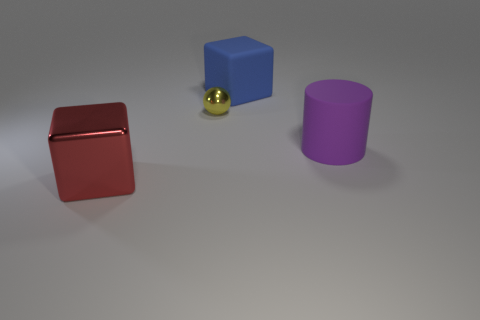How many objects are big matte cubes or red metallic things?
Keep it short and to the point. 2. Do the matte cylinder and the tiny metallic thing have the same color?
Offer a very short reply. No. Are there any other things that have the same size as the purple cylinder?
Make the answer very short. Yes. There is a small yellow shiny thing that is behind the red object that is to the left of the large rubber cylinder; what is its shape?
Give a very brief answer. Sphere. Is the number of large things less than the number of tiny shiny spheres?
Your response must be concise. No. There is a thing that is in front of the tiny yellow object and behind the large metal block; what size is it?
Ensure brevity in your answer.  Large. Does the yellow metal thing have the same size as the purple matte object?
Give a very brief answer. No. Do the matte object in front of the small ball and the tiny metallic thing have the same color?
Your response must be concise. No. How many large red blocks are behind the small metal sphere?
Offer a very short reply. 0. Is the number of small blue metallic blocks greater than the number of big blocks?
Your answer should be compact. No. 